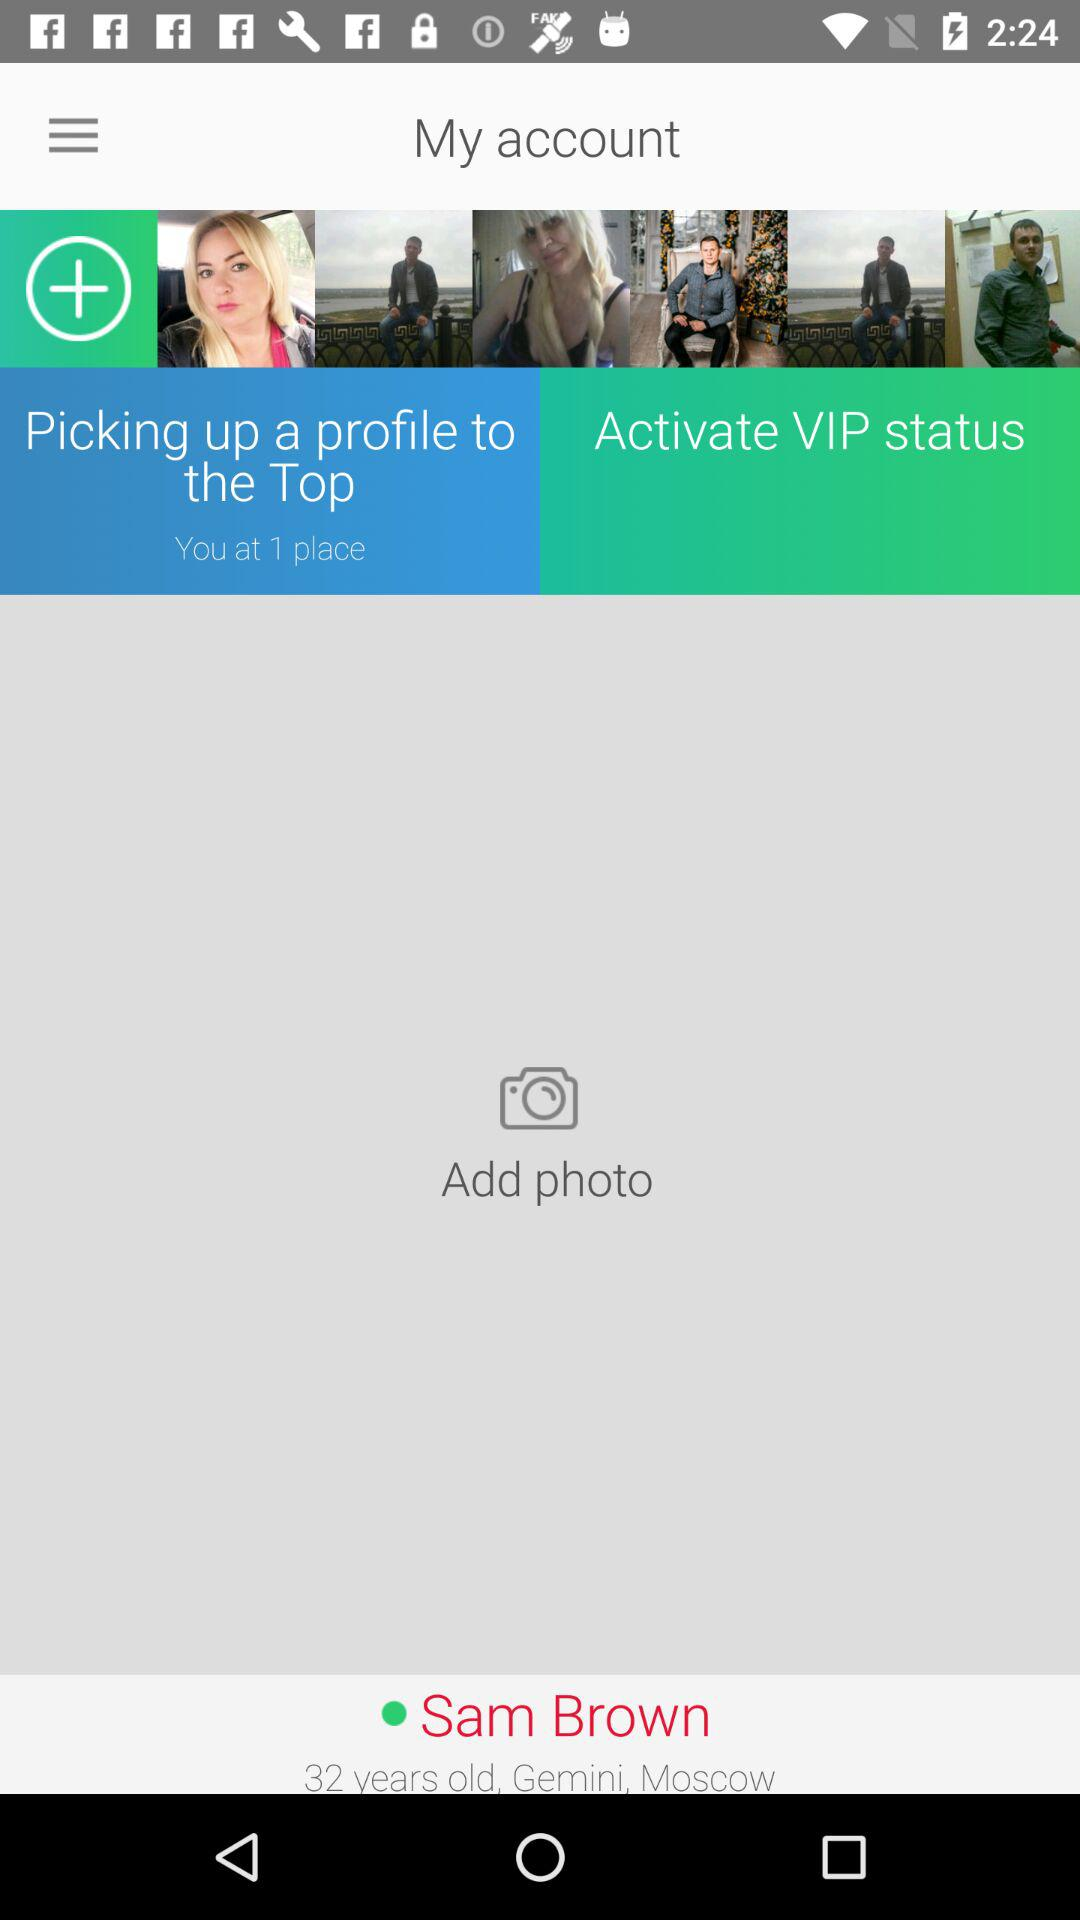What is the user name? The user name is Sam Brown. 